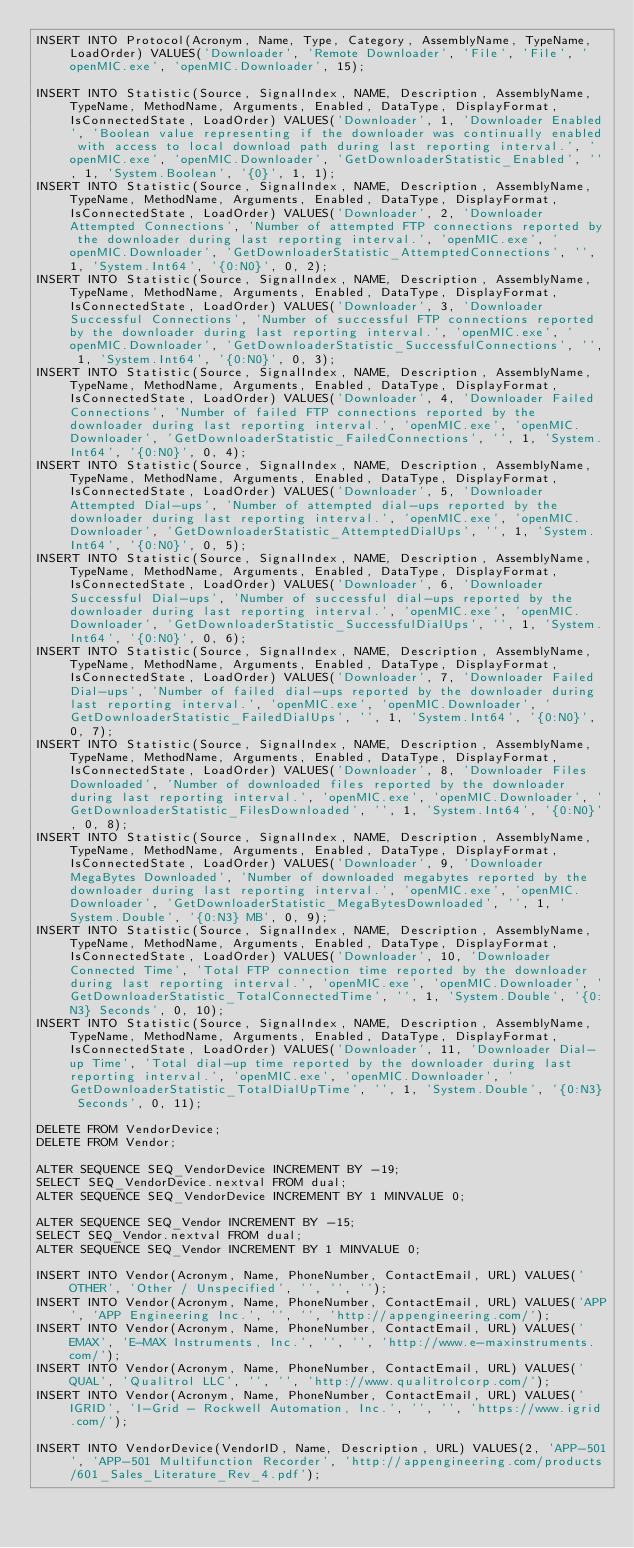Convert code to text. <code><loc_0><loc_0><loc_500><loc_500><_SQL_>INSERT INTO Protocol(Acronym, Name, Type, Category, AssemblyName, TypeName, LoadOrder) VALUES('Downloader', 'Remote Downloader', 'File', 'File', 'openMIC.exe', 'openMIC.Downloader', 15);

INSERT INTO Statistic(Source, SignalIndex, NAME, Description, AssemblyName, TypeName, MethodName, Arguments, Enabled, DataType, DisplayFormat, IsConnectedState, LoadOrder) VALUES('Downloader', 1, 'Downloader Enabled', 'Boolean value representing if the downloader was continually enabled with access to local download path during last reporting interval.', 'openMIC.exe', 'openMIC.Downloader', 'GetDownloaderStatistic_Enabled', '', 1, 'System.Boolean', '{0}', 1, 1);
INSERT INTO Statistic(Source, SignalIndex, NAME, Description, AssemblyName, TypeName, MethodName, Arguments, Enabled, DataType, DisplayFormat, IsConnectedState, LoadOrder) VALUES('Downloader', 2, 'Downloader Attempted Connections', 'Number of attempted FTP connections reported by the downloader during last reporting interval.', 'openMIC.exe', 'openMIC.Downloader', 'GetDownloaderStatistic_AttemptedConnections', '', 1, 'System.Int64', '{0:N0}', 0, 2);
INSERT INTO Statistic(Source, SignalIndex, NAME, Description, AssemblyName, TypeName, MethodName, Arguments, Enabled, DataType, DisplayFormat, IsConnectedState, LoadOrder) VALUES('Downloader', 3, 'Downloader Successful Connections', 'Number of successful FTP connections reported by the downloader during last reporting interval.', 'openMIC.exe', 'openMIC.Downloader', 'GetDownloaderStatistic_SuccessfulConnections', '', 1, 'System.Int64', '{0:N0}', 0, 3);
INSERT INTO Statistic(Source, SignalIndex, NAME, Description, AssemblyName, TypeName, MethodName, Arguments, Enabled, DataType, DisplayFormat, IsConnectedState, LoadOrder) VALUES('Downloader', 4, 'Downloader Failed Connections', 'Number of failed FTP connections reported by the downloader during last reporting interval.', 'openMIC.exe', 'openMIC.Downloader', 'GetDownloaderStatistic_FailedConnections', '', 1, 'System.Int64', '{0:N0}', 0, 4);
INSERT INTO Statistic(Source, SignalIndex, NAME, Description, AssemblyName, TypeName, MethodName, Arguments, Enabled, DataType, DisplayFormat, IsConnectedState, LoadOrder) VALUES('Downloader', 5, 'Downloader Attempted Dial-ups', 'Number of attempted dial-ups reported by the downloader during last reporting interval.', 'openMIC.exe', 'openMIC.Downloader', 'GetDownloaderStatistic_AttemptedDialUps', '', 1, 'System.Int64', '{0:N0}', 0, 5);
INSERT INTO Statistic(Source, SignalIndex, NAME, Description, AssemblyName, TypeName, MethodName, Arguments, Enabled, DataType, DisplayFormat, IsConnectedState, LoadOrder) VALUES('Downloader', 6, 'Downloader Successful Dial-ups', 'Number of successful dial-ups reported by the downloader during last reporting interval.', 'openMIC.exe', 'openMIC.Downloader', 'GetDownloaderStatistic_SuccessfulDialUps', '', 1, 'System.Int64', '{0:N0}', 0, 6);
INSERT INTO Statistic(Source, SignalIndex, NAME, Description, AssemblyName, TypeName, MethodName, Arguments, Enabled, DataType, DisplayFormat, IsConnectedState, LoadOrder) VALUES('Downloader', 7, 'Downloader Failed Dial-ups', 'Number of failed dial-ups reported by the downloader during last reporting interval.', 'openMIC.exe', 'openMIC.Downloader', 'GetDownloaderStatistic_FailedDialUps', '', 1, 'System.Int64', '{0:N0}', 0, 7);
INSERT INTO Statistic(Source, SignalIndex, NAME, Description, AssemblyName, TypeName, MethodName, Arguments, Enabled, DataType, DisplayFormat, IsConnectedState, LoadOrder) VALUES('Downloader', 8, 'Downloader Files Downloaded', 'Number of downloaded files reported by the downloader during last reporting interval.', 'openMIC.exe', 'openMIC.Downloader', 'GetDownloaderStatistic_FilesDownloaded', '', 1, 'System.Int64', '{0:N0}', 0, 8);
INSERT INTO Statistic(Source, SignalIndex, NAME, Description, AssemblyName, TypeName, MethodName, Arguments, Enabled, DataType, DisplayFormat, IsConnectedState, LoadOrder) VALUES('Downloader', 9, 'Downloader MegaBytes Downloaded', 'Number of downloaded megabytes reported by the downloader during last reporting interval.', 'openMIC.exe', 'openMIC.Downloader', 'GetDownloaderStatistic_MegaBytesDownloaded', '', 1, 'System.Double', '{0:N3} MB', 0, 9);
INSERT INTO Statistic(Source, SignalIndex, NAME, Description, AssemblyName, TypeName, MethodName, Arguments, Enabled, DataType, DisplayFormat, IsConnectedState, LoadOrder) VALUES('Downloader', 10, 'Downloader Connected Time', 'Total FTP connection time reported by the downloader during last reporting interval.', 'openMIC.exe', 'openMIC.Downloader', 'GetDownloaderStatistic_TotalConnectedTime', '', 1, 'System.Double', '{0:N3} Seconds', 0, 10);
INSERT INTO Statistic(Source, SignalIndex, NAME, Description, AssemblyName, TypeName, MethodName, Arguments, Enabled, DataType, DisplayFormat, IsConnectedState, LoadOrder) VALUES('Downloader', 11, 'Downloader Dial-up Time', 'Total dial-up time reported by the downloader during last reporting interval.', 'openMIC.exe', 'openMIC.Downloader', 'GetDownloaderStatistic_TotalDialUpTime', '', 1, 'System.Double', '{0:N3} Seconds', 0, 11);

DELETE FROM VendorDevice;
DELETE FROM Vendor;

ALTER SEQUENCE SEQ_VendorDevice INCREMENT BY -19;
SELECT SEQ_VendorDevice.nextval FROM dual;
ALTER SEQUENCE SEQ_VendorDevice INCREMENT BY 1 MINVALUE 0;

ALTER SEQUENCE SEQ_Vendor INCREMENT BY -15;
SELECT SEQ_Vendor.nextval FROM dual;
ALTER SEQUENCE SEQ_Vendor INCREMENT BY 1 MINVALUE 0;

INSERT INTO Vendor(Acronym, Name, PhoneNumber, ContactEmail, URL) VALUES('OTHER', 'Other / Unspecified', '', '', '');
INSERT INTO Vendor(Acronym, Name, PhoneNumber, ContactEmail, URL) VALUES('APP', 'APP Engineering Inc.', '', '', 'http://appengineering.com/');
INSERT INTO Vendor(Acronym, Name, PhoneNumber, ContactEmail, URL) VALUES('EMAX', 'E-MAX Instruments, Inc.', '', '', 'http://www.e-maxinstruments.com/');
INSERT INTO Vendor(Acronym, Name, PhoneNumber, ContactEmail, URL) VALUES('QUAL', 'Qualitrol LLC', '', '', 'http://www.qualitrolcorp.com/');
INSERT INTO Vendor(Acronym, Name, PhoneNumber, ContactEmail, URL) VALUES('IGRID', 'I-Grid - Rockwell Automation, Inc.', '', '', 'https://www.igrid.com/');

INSERT INTO VendorDevice(VendorID, Name, Description, URL) VALUES(2, 'APP-501', 'APP-501 Multifunction Recorder', 'http://appengineering.com/products/601_Sales_Literature_Rev_4.pdf');</code> 